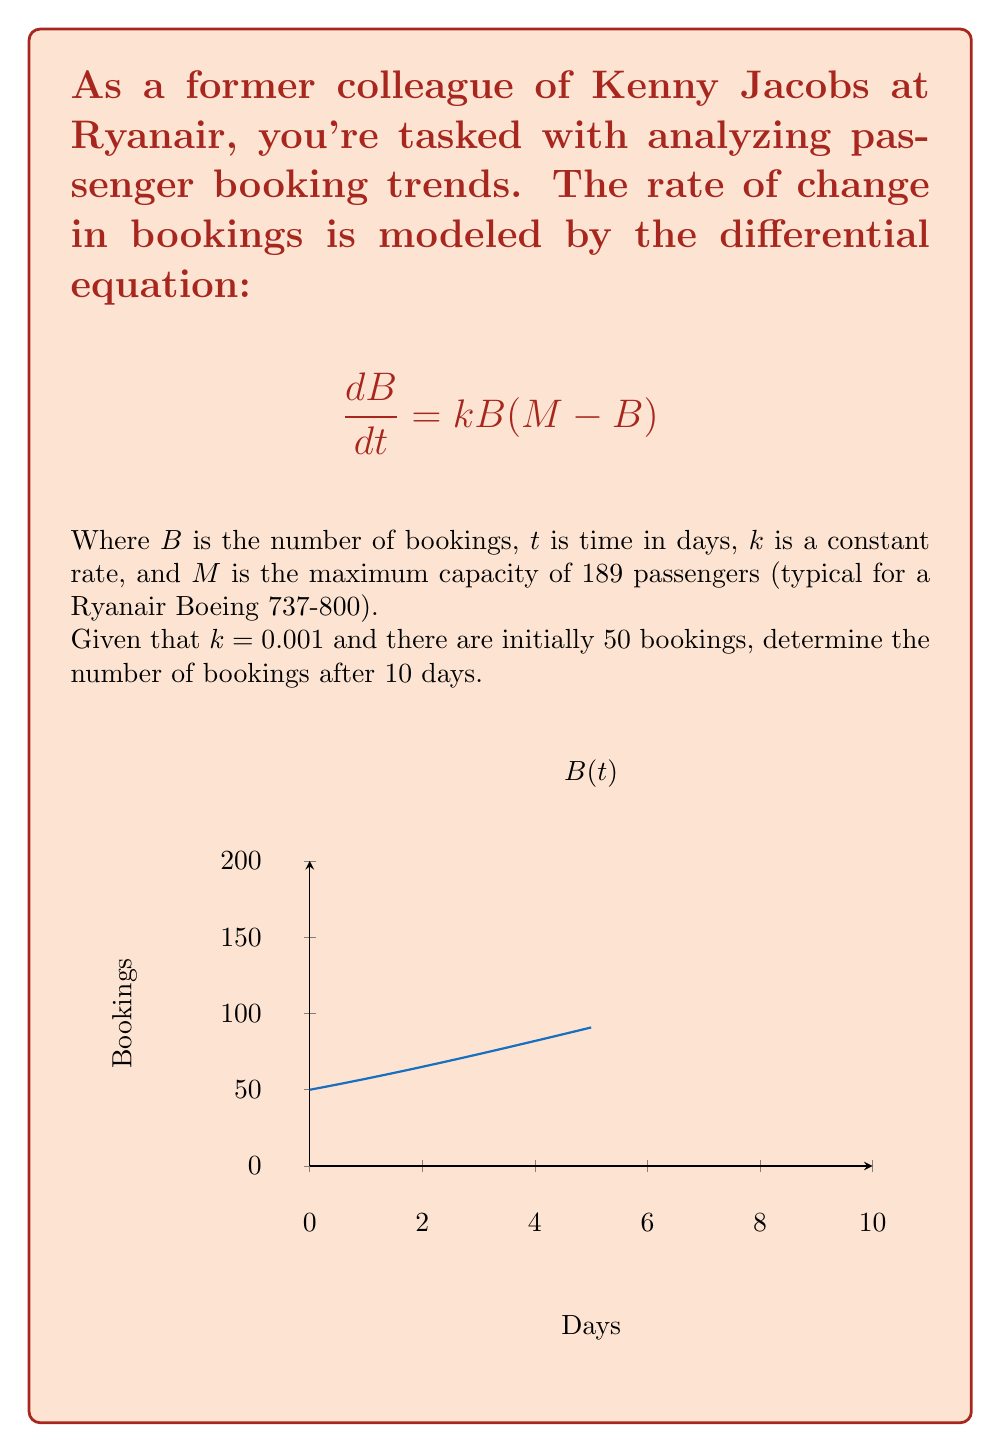Give your solution to this math problem. Let's solve this step-by-step:

1) We have the differential equation: $$\frac{dB}{dt} = kB(M-B)$$

2) This is a logistic growth model. The solution to this equation is:

   $$B(t) = \frac{M}{1 + Ce^{-kMt}}$$

   where $C$ is a constant we need to determine.

3) We know the initial condition: $B(0) = 50$. Let's use this to find $C$:

   $$50 = \frac{189}{1 + C}$$

   $$C = \frac{189}{50} - 1 = 2.78$$

4) Now our solution is:

   $$B(t) = \frac{189}{1 + 2.78e^{-0.001 \cdot 189 \cdot t}}$$

5) We want to find $B(10)$, so let's substitute $t=10$:

   $$B(10) = \frac{189}{1 + 2.78e^{-0.001 \cdot 189 \cdot 10}}$$

6) Simplifying:

   $$B(10) = \frac{189}{1 + 2.78e^{-1.89}}$$

7) Calculating this:

   $$B(10) \approx 97.86$$

8) Since we're dealing with whole passengers, we round to the nearest integer.
Answer: 98 bookings 